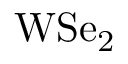Convert formula to latex. <formula><loc_0><loc_0><loc_500><loc_500>W S e _ { 2 }</formula> 